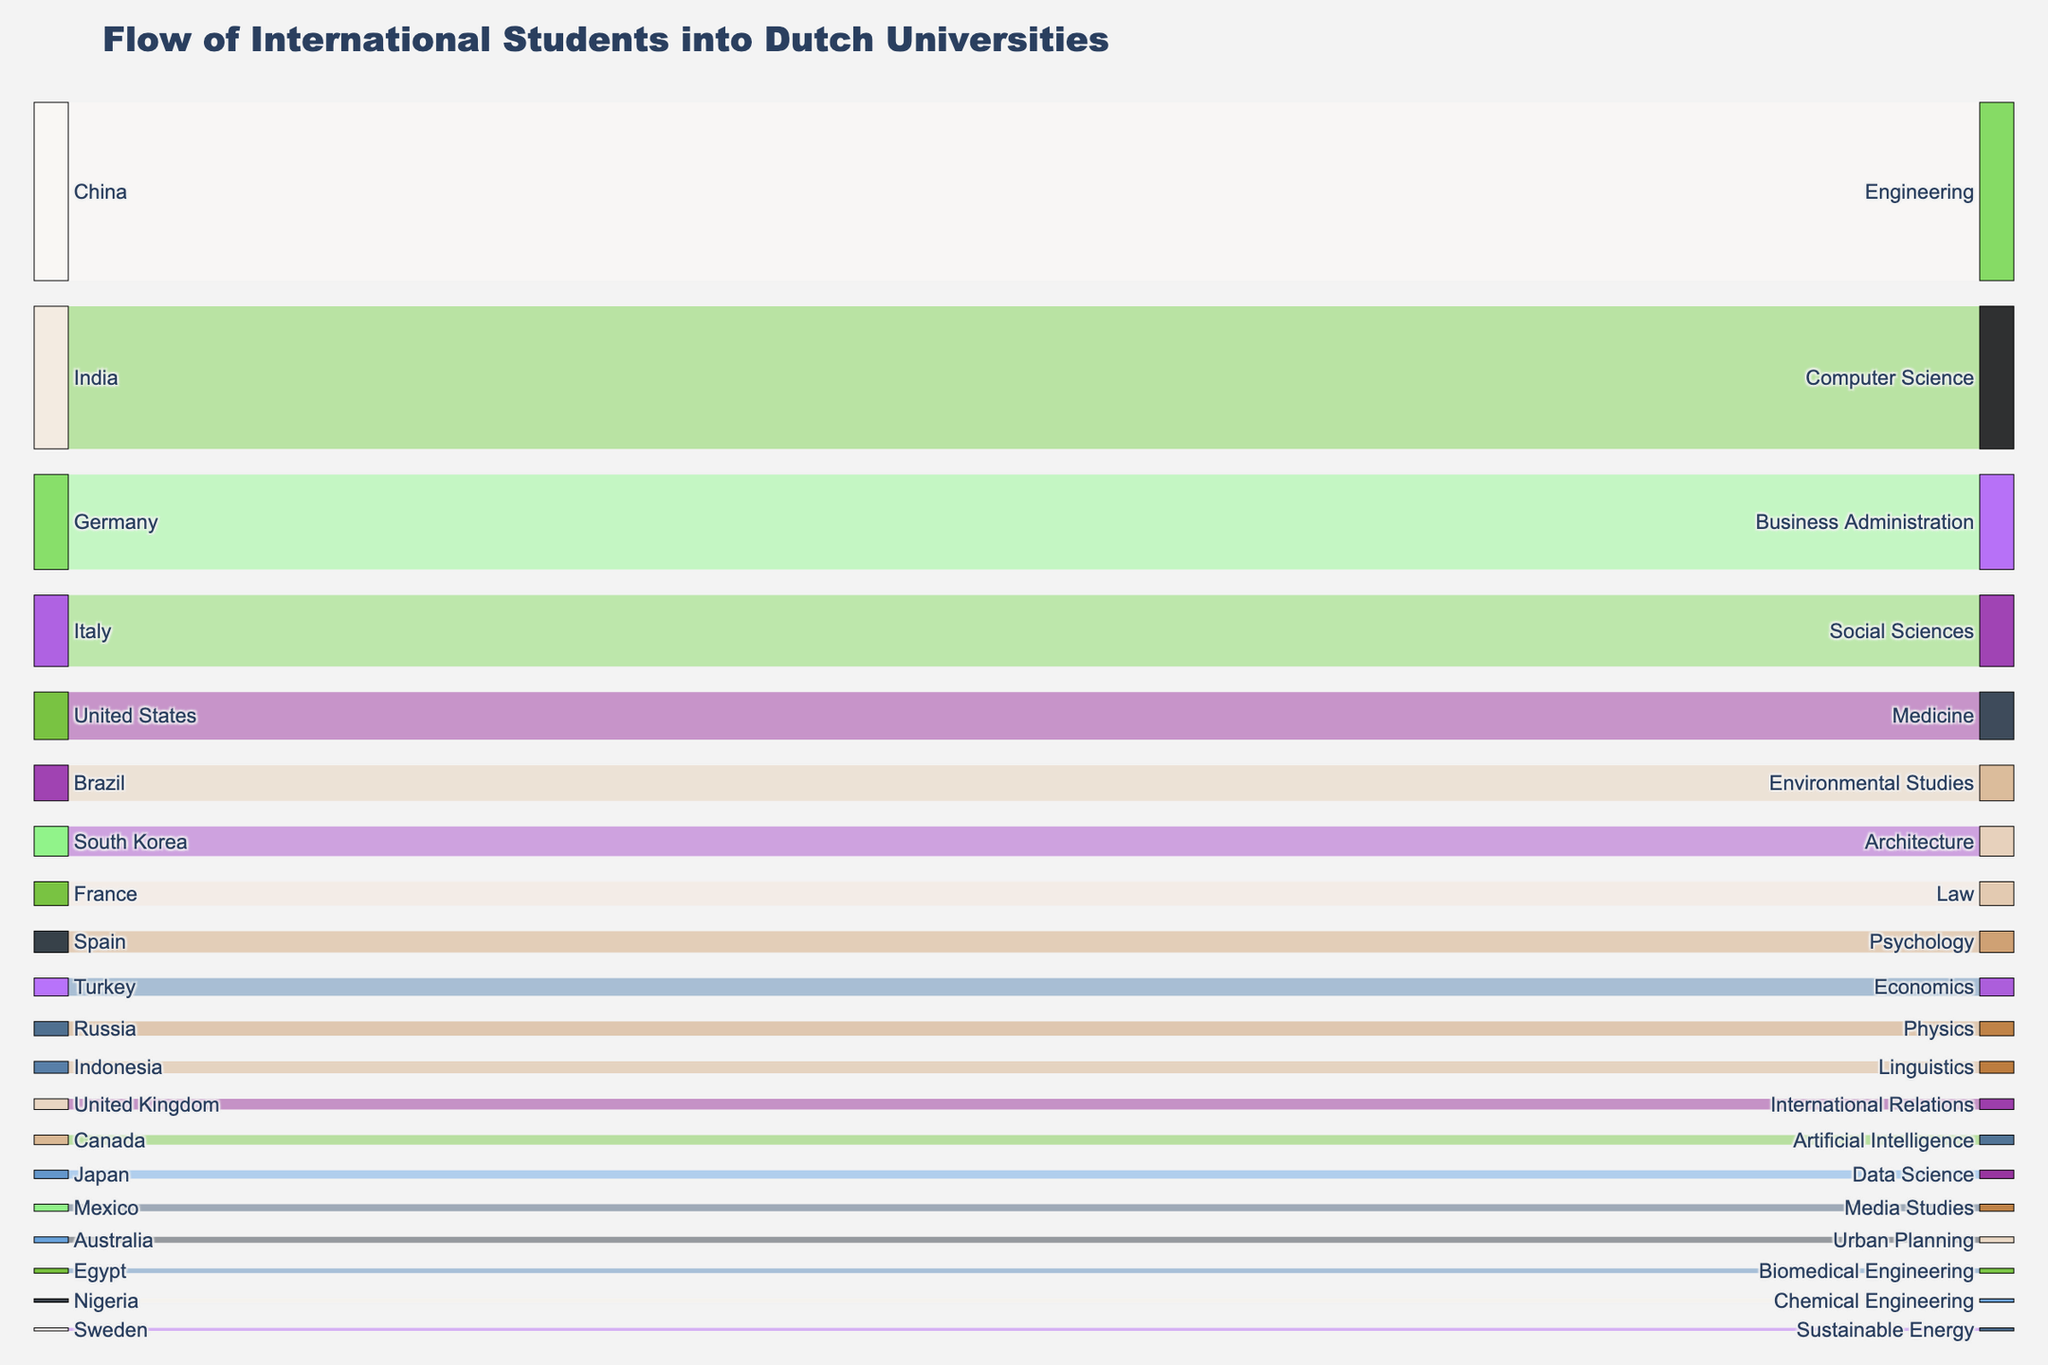What is the title of the Sankey diagram? The title of the Sankey diagram is displayed at the top of the figure and gives an overview of what the data represents.
Answer: Flow of International Students into Dutch Universities How many source countries are represented in the diagram? Count the number of unique countries listed on the left side of the diagram.
Answer: 20 Which field of study attracts the most students from India? Follow the flow from India on the left side of the diagram to see which field on the right side receives the largest flow.
Answer: Computer Science What is the smallest value represented in the Sankey diagram, and which country and field does it correspond to? Look at the values associated with the flows and find the smallest one, then trace it back to the corresponding country and field.
Answer: 25, Sweden, Sustainable Energy How many students from China are studying Engineering in Dutch universities? Locate the flow from China to Engineering and note the value indicated.
Answer: 1500 Which field of study has the highest number of incoming students from the United States? Find the flow from the United States and identify the field with the largest value.
Answer: Medicine What is the total number of students from Germany and Italy combined who choose to study in Dutch universities? Sum up the values of students from Germany and Italy by adding 800 (Germany) and 600 (Italy).
Answer: 1400 Which country sends more students to the field of Law, France or Spain? Compare the values of students flowing from France and Spain to the field of Law.
Answer: France What is the combined total of students studying Engineering and Computer Science from China and India? Add the values of students from China studying Engineering (1500) and students from India studying Computer Science (1200).
Answer: 2700 